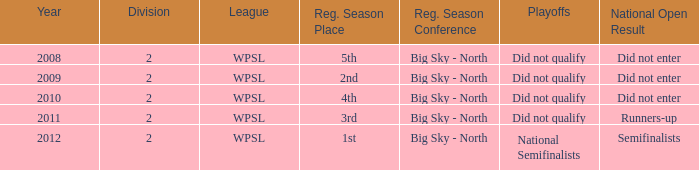What league was involved in 2010? WPSL. 